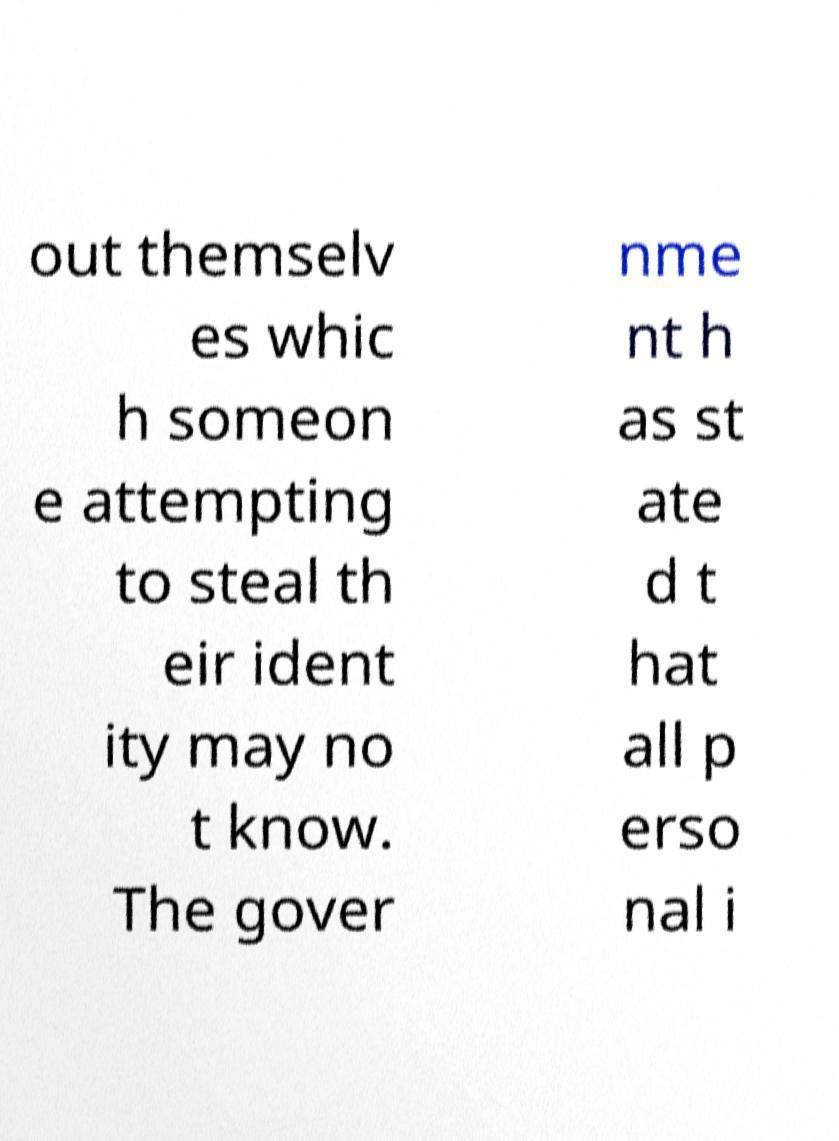For documentation purposes, I need the text within this image transcribed. Could you provide that? out themselv es whic h someon e attempting to steal th eir ident ity may no t know. The gover nme nt h as st ate d t hat all p erso nal i 